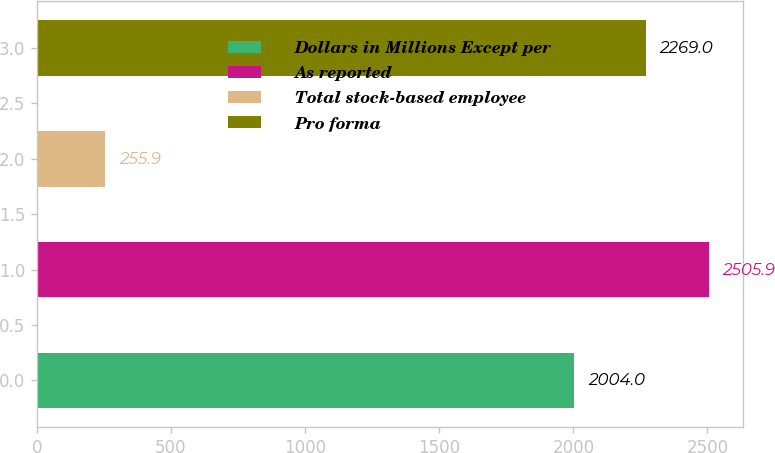Convert chart to OTSL. <chart><loc_0><loc_0><loc_500><loc_500><bar_chart><fcel>Dollars in Millions Except per<fcel>As reported<fcel>Total stock-based employee<fcel>Pro forma<nl><fcel>2004<fcel>2505.9<fcel>255.9<fcel>2269<nl></chart> 